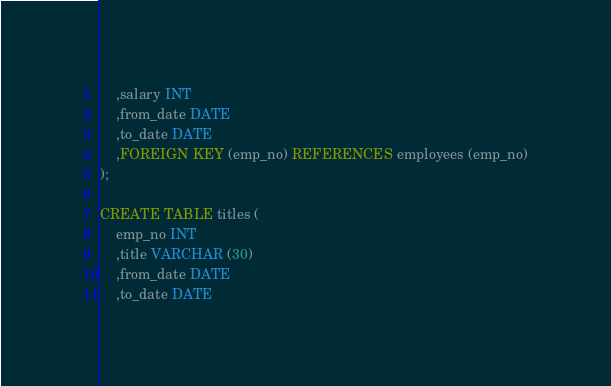Convert code to text. <code><loc_0><loc_0><loc_500><loc_500><_SQL_>	,salary INT
	,from_date DATE
	,to_date DATE
	,FOREIGN KEY (emp_no) REFERENCES employees (emp_no)
);

CREATE TABLE titles (
	emp_no INT
	,title VARCHAR (30)
	,from_date DATE
	,to_date DATE</code> 